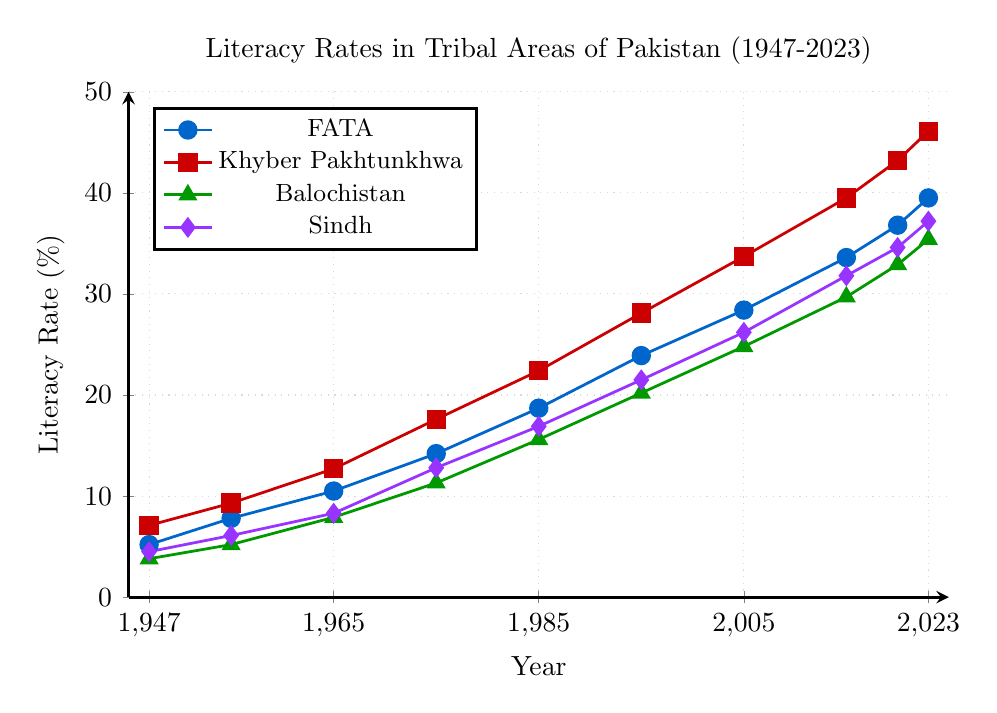Which tribal area had the highest literacy rate in 2023? Identify the points at 2023 for each area by looking at the far right end of the lines. Compare the heights of the marks. Khyber Pakhtunkhwa has the highest mark at 46.1%.
Answer: Khyber Pakhtunkhwa What was the difference in literacy rates between Khyber Pakhtunkhwa and Balochistan in 1985? At 1985, identify the literacy rates for Khyber Pakhtunkhwa and Balochistan by looking for the heights of the points on their respective lines. Khyber Pakhtunkhwa had a rate of 22.4%, and Balochistan had a rate of 15.6%. Subtract the two: 22.4% - 15.6% = 6.8%.
Answer: 6.8% What is the general trend in literacy rates for the Federally Administered Tribal Areas (FATA) from 1947 to 2023? Observe the line corresponding to FATA from 1947 to 2023. It starts at 5.2% and ends at 39.5%. The line consistently ascends, indicating a general increasing trend in literacy rates.
Answer: Increasing Which year showed the greatest increase in literacy rate for Sindh Tribal Areas? Compare the intervals between consecutive points of Sindh's line to find the largest vertical difference. Between 1965 and 1975, the rate increased from 8.3% to 12.8%, making a change of 4.5%, which is the greatest single-year interval change in the dataset.
Answer: 1975 How does the literacy rate growth between 1947 and 2023 in Sindh Tribal Areas compare to that in Balochistan Tribal Areas? In 1947, Sindh had a literacy rate of 4.5%, and in 2023, it was 37.2%. For Balochistan, the rates were 3.8% in 1947 and 35.4% in 2023. Calculate the growth: Sindh's growth is 37.2% - 4.5% = 32.7%; Balochistan's growth is 35.4% - 3.8% = 31.6%. Sindh's growth is slightly higher.
Answer: Sindh had higher growth Which tribal area had the lowest literacy rate consistently till 1965? From 1947 to 1965, compare the lowest points from the beginning of the lines to 1965. Balochistan consistently reflects the lowest heights among the lines, with a starting value of 3.8%in 1947 and 7.9% in 1965.
Answer: Balochistan 